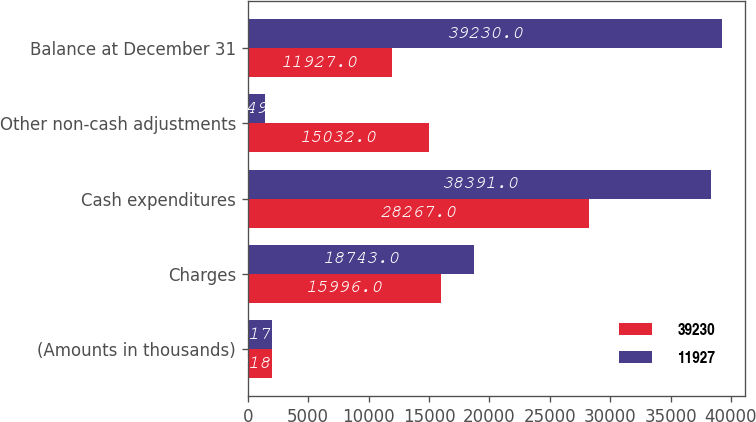<chart> <loc_0><loc_0><loc_500><loc_500><stacked_bar_chart><ecel><fcel>(Amounts in thousands)<fcel>Charges<fcel>Cash expenditures<fcel>Other non-cash adjustments<fcel>Balance at December 31<nl><fcel>39230<fcel>2018<fcel>15996<fcel>28267<fcel>15032<fcel>11927<nl><fcel>11927<fcel>2017<fcel>18743<fcel>38391<fcel>1449<fcel>39230<nl></chart> 